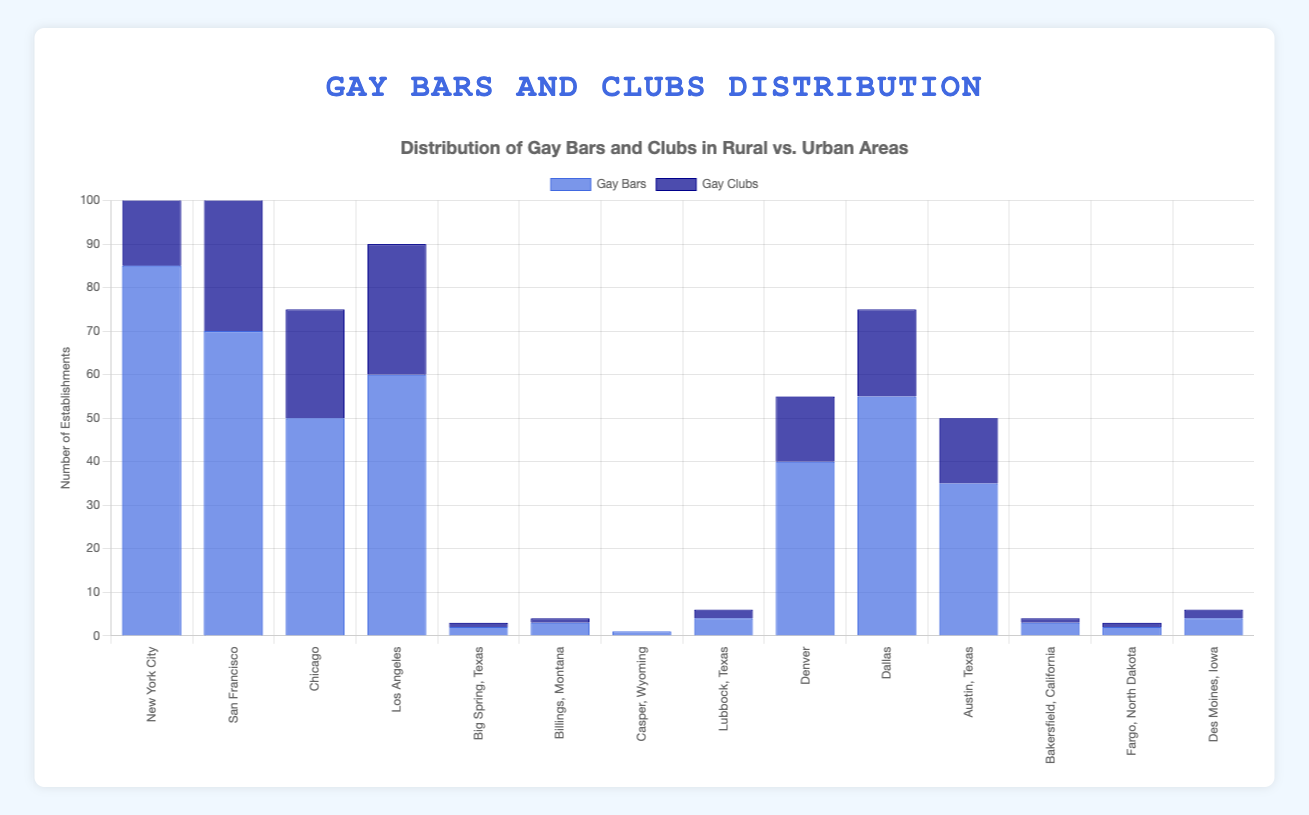What's the total number of gay bars in urban areas? To find the total number of gay bars in urban areas, sum the number of gay bars listed for each urban area: New York City (85), San Francisco (70), Chicago (50), Los Angeles (60), Denver (40), Dallas (55), Austin (35). The calculation is 85 + 70 + 50 + 60 + 40 + 55 + 35 = 395
Answer: 395 Which rural area has the highest number of gay clubs? By examining the plotted data, note the number of gay clubs in each rural area. Lubbock, Texas and Des Moines, Iowa both have the highest number, with 2 gay clubs each.
Answer: Lubbock, Texas and Des Moines, Iowa How many more gay bars are there in New York City compared to Los Angeles? Find the difference in the number of gay bars between New York City (85) and Los Angeles (60): 85 - 60 = 25
Answer: 25 Which area has the least number of gay bars? Evaluate the bars representing gay bars in each area. Casper, Wyoming has the smallest bar with 1 gay bar.
Answer: Casper, Wyoming What is the average number of gay clubs in urban areas? To find the average, sum the number of gay clubs in urban areas (New York City: 45, San Francisco: 40, Chicago: 25, Los Angeles: 30, Denver: 15, Dallas: 20, Austin: 15) and divide by the number of urban areas (7). Calculation: (45 + 40 + 25 + 30 + 15 + 20 + 15) / 7 = 190 / 7 ≈ 27.14
Answer: 27.14 Which urban area has more gay bars: Chicago or Dallas? Compare the heights of the bars representing gay bars in Chicago (50) and Dallas (55). Dallas has more gay bars.
Answer: Dallas Is there any rural area with more than three gay bars? Examine the values of gay bars in rural areas and notice that Lubbock, Texas and Des Moines, Iowa both have 4 gay bars, which is more than three.
Answer: Yes What is the combined number of gay clubs in urban areas? Sum the number of gay clubs in each urban area: New York City (45), San Francisco (40), Chicago (25), Los Angeles (30), Denver (15), Dallas (20), Austin (15). Calculation: 45 + 40 + 25 + 30 + 15 + 20 + 15 = 190
Answer: 190 